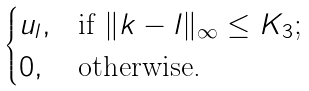Convert formula to latex. <formula><loc_0><loc_0><loc_500><loc_500>\begin{cases} u _ { l } , & \text {if $\|k-l\|_{\infty} \leq K_{3}$;} \\ 0 , & \text {otherwise.} \end{cases}</formula> 